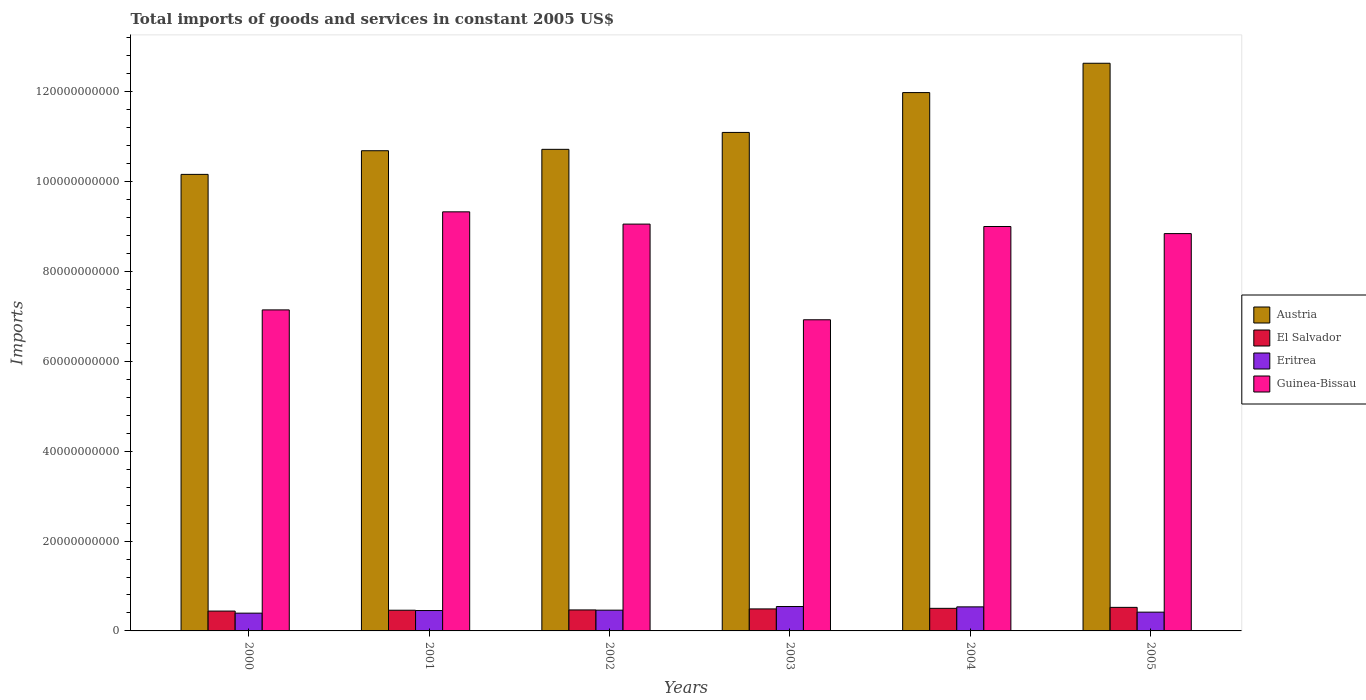How many different coloured bars are there?
Offer a very short reply. 4. How many bars are there on the 4th tick from the left?
Your answer should be compact. 4. How many bars are there on the 5th tick from the right?
Your response must be concise. 4. What is the total imports of goods and services in Guinea-Bissau in 2003?
Offer a terse response. 6.93e+1. Across all years, what is the maximum total imports of goods and services in El Salvador?
Keep it short and to the point. 5.24e+09. Across all years, what is the minimum total imports of goods and services in Eritrea?
Give a very brief answer. 3.96e+09. In which year was the total imports of goods and services in Eritrea minimum?
Make the answer very short. 2000. What is the total total imports of goods and services in Guinea-Bissau in the graph?
Provide a short and direct response. 5.03e+11. What is the difference between the total imports of goods and services in El Salvador in 2004 and that in 2005?
Provide a short and direct response. -2.18e+08. What is the difference between the total imports of goods and services in El Salvador in 2001 and the total imports of goods and services in Austria in 2004?
Make the answer very short. -1.15e+11. What is the average total imports of goods and services in Austria per year?
Your answer should be compact. 1.12e+11. In the year 2005, what is the difference between the total imports of goods and services in Guinea-Bissau and total imports of goods and services in El Salvador?
Your answer should be compact. 8.32e+1. What is the ratio of the total imports of goods and services in Austria in 2000 to that in 2002?
Give a very brief answer. 0.95. Is the difference between the total imports of goods and services in Guinea-Bissau in 2001 and 2005 greater than the difference between the total imports of goods and services in El Salvador in 2001 and 2005?
Provide a succinct answer. Yes. What is the difference between the highest and the second highest total imports of goods and services in Guinea-Bissau?
Keep it short and to the point. 2.73e+09. What is the difference between the highest and the lowest total imports of goods and services in Eritrea?
Your response must be concise. 1.47e+09. In how many years, is the total imports of goods and services in Eritrea greater than the average total imports of goods and services in Eritrea taken over all years?
Provide a succinct answer. 2. Is the sum of the total imports of goods and services in Guinea-Bissau in 2004 and 2005 greater than the maximum total imports of goods and services in Eritrea across all years?
Provide a succinct answer. Yes. What does the 4th bar from the left in 2001 represents?
Offer a very short reply. Guinea-Bissau. What does the 3rd bar from the right in 2001 represents?
Keep it short and to the point. El Salvador. Is it the case that in every year, the sum of the total imports of goods and services in Austria and total imports of goods and services in Eritrea is greater than the total imports of goods and services in Guinea-Bissau?
Your answer should be compact. Yes. How many bars are there?
Offer a terse response. 24. How many years are there in the graph?
Offer a terse response. 6. Are the values on the major ticks of Y-axis written in scientific E-notation?
Provide a short and direct response. No. Does the graph contain any zero values?
Keep it short and to the point. No. Does the graph contain grids?
Your answer should be compact. No. How many legend labels are there?
Offer a very short reply. 4. How are the legend labels stacked?
Keep it short and to the point. Vertical. What is the title of the graph?
Provide a short and direct response. Total imports of goods and services in constant 2005 US$. What is the label or title of the Y-axis?
Keep it short and to the point. Imports. What is the Imports of Austria in 2000?
Provide a succinct answer. 1.02e+11. What is the Imports in El Salvador in 2000?
Your answer should be compact. 4.42e+09. What is the Imports in Eritrea in 2000?
Ensure brevity in your answer.  3.96e+09. What is the Imports in Guinea-Bissau in 2000?
Your answer should be very brief. 7.15e+1. What is the Imports in Austria in 2001?
Keep it short and to the point. 1.07e+11. What is the Imports of El Salvador in 2001?
Give a very brief answer. 4.61e+09. What is the Imports in Eritrea in 2001?
Your answer should be compact. 4.54e+09. What is the Imports of Guinea-Bissau in 2001?
Your answer should be very brief. 9.33e+1. What is the Imports of Austria in 2002?
Offer a terse response. 1.07e+11. What is the Imports of El Salvador in 2002?
Make the answer very short. 4.67e+09. What is the Imports in Eritrea in 2002?
Your answer should be compact. 4.62e+09. What is the Imports in Guinea-Bissau in 2002?
Provide a succinct answer. 9.06e+1. What is the Imports in Austria in 2003?
Ensure brevity in your answer.  1.11e+11. What is the Imports of El Salvador in 2003?
Your response must be concise. 4.90e+09. What is the Imports in Eritrea in 2003?
Offer a very short reply. 5.43e+09. What is the Imports in Guinea-Bissau in 2003?
Give a very brief answer. 6.93e+1. What is the Imports in Austria in 2004?
Offer a very short reply. 1.20e+11. What is the Imports in El Salvador in 2004?
Make the answer very short. 5.03e+09. What is the Imports of Eritrea in 2004?
Your response must be concise. 5.35e+09. What is the Imports in Guinea-Bissau in 2004?
Ensure brevity in your answer.  9.00e+1. What is the Imports in Austria in 2005?
Give a very brief answer. 1.26e+11. What is the Imports in El Salvador in 2005?
Your answer should be very brief. 5.24e+09. What is the Imports in Eritrea in 2005?
Keep it short and to the point. 4.18e+09. What is the Imports in Guinea-Bissau in 2005?
Provide a short and direct response. 8.84e+1. Across all years, what is the maximum Imports of Austria?
Your answer should be very brief. 1.26e+11. Across all years, what is the maximum Imports of El Salvador?
Give a very brief answer. 5.24e+09. Across all years, what is the maximum Imports in Eritrea?
Your response must be concise. 5.43e+09. Across all years, what is the maximum Imports in Guinea-Bissau?
Provide a succinct answer. 9.33e+1. Across all years, what is the minimum Imports in Austria?
Ensure brevity in your answer.  1.02e+11. Across all years, what is the minimum Imports of El Salvador?
Keep it short and to the point. 4.42e+09. Across all years, what is the minimum Imports in Eritrea?
Offer a terse response. 3.96e+09. Across all years, what is the minimum Imports in Guinea-Bissau?
Your answer should be compact. 6.93e+1. What is the total Imports in Austria in the graph?
Your answer should be very brief. 6.73e+11. What is the total Imports in El Salvador in the graph?
Give a very brief answer. 2.89e+1. What is the total Imports in Eritrea in the graph?
Provide a short and direct response. 2.81e+1. What is the total Imports in Guinea-Bissau in the graph?
Make the answer very short. 5.03e+11. What is the difference between the Imports in Austria in 2000 and that in 2001?
Your answer should be compact. -5.26e+09. What is the difference between the Imports of El Salvador in 2000 and that in 2001?
Make the answer very short. -1.87e+08. What is the difference between the Imports of Eritrea in 2000 and that in 2001?
Your response must be concise. -5.78e+08. What is the difference between the Imports in Guinea-Bissau in 2000 and that in 2001?
Offer a very short reply. -2.18e+1. What is the difference between the Imports in Austria in 2000 and that in 2002?
Your answer should be compact. -5.58e+09. What is the difference between the Imports of El Salvador in 2000 and that in 2002?
Your response must be concise. -2.54e+08. What is the difference between the Imports of Eritrea in 2000 and that in 2002?
Your answer should be very brief. -6.64e+08. What is the difference between the Imports in Guinea-Bissau in 2000 and that in 2002?
Provide a short and direct response. -1.91e+1. What is the difference between the Imports of Austria in 2000 and that in 2003?
Provide a short and direct response. -9.34e+09. What is the difference between the Imports in El Salvador in 2000 and that in 2003?
Offer a terse response. -4.81e+08. What is the difference between the Imports in Eritrea in 2000 and that in 2003?
Offer a terse response. -1.47e+09. What is the difference between the Imports in Guinea-Bissau in 2000 and that in 2003?
Keep it short and to the point. 2.20e+09. What is the difference between the Imports of Austria in 2000 and that in 2004?
Offer a terse response. -1.82e+1. What is the difference between the Imports of El Salvador in 2000 and that in 2004?
Your response must be concise. -6.08e+08. What is the difference between the Imports in Eritrea in 2000 and that in 2004?
Offer a terse response. -1.40e+09. What is the difference between the Imports of Guinea-Bissau in 2000 and that in 2004?
Give a very brief answer. -1.86e+1. What is the difference between the Imports of Austria in 2000 and that in 2005?
Provide a succinct answer. -2.47e+1. What is the difference between the Imports of El Salvador in 2000 and that in 2005?
Offer a terse response. -8.26e+08. What is the difference between the Imports of Eritrea in 2000 and that in 2005?
Provide a succinct answer. -2.19e+08. What is the difference between the Imports in Guinea-Bissau in 2000 and that in 2005?
Your answer should be very brief. -1.70e+1. What is the difference between the Imports of Austria in 2001 and that in 2002?
Provide a short and direct response. -3.12e+08. What is the difference between the Imports in El Salvador in 2001 and that in 2002?
Give a very brief answer. -6.77e+07. What is the difference between the Imports of Eritrea in 2001 and that in 2002?
Make the answer very short. -8.56e+07. What is the difference between the Imports of Guinea-Bissau in 2001 and that in 2002?
Your answer should be very brief. 2.73e+09. What is the difference between the Imports of Austria in 2001 and that in 2003?
Your response must be concise. -4.07e+09. What is the difference between the Imports in El Salvador in 2001 and that in 2003?
Ensure brevity in your answer.  -2.94e+08. What is the difference between the Imports of Eritrea in 2001 and that in 2003?
Provide a succinct answer. -8.95e+08. What is the difference between the Imports in Guinea-Bissau in 2001 and that in 2003?
Provide a succinct answer. 2.40e+1. What is the difference between the Imports in Austria in 2001 and that in 2004?
Offer a terse response. -1.29e+1. What is the difference between the Imports in El Salvador in 2001 and that in 2004?
Provide a short and direct response. -4.21e+08. What is the difference between the Imports of Eritrea in 2001 and that in 2004?
Your answer should be compact. -8.19e+08. What is the difference between the Imports in Guinea-Bissau in 2001 and that in 2004?
Give a very brief answer. 3.27e+09. What is the difference between the Imports in Austria in 2001 and that in 2005?
Ensure brevity in your answer.  -1.95e+1. What is the difference between the Imports of El Salvador in 2001 and that in 2005?
Your answer should be very brief. -6.39e+08. What is the difference between the Imports in Eritrea in 2001 and that in 2005?
Provide a short and direct response. 3.59e+08. What is the difference between the Imports of Guinea-Bissau in 2001 and that in 2005?
Offer a very short reply. 4.84e+09. What is the difference between the Imports of Austria in 2002 and that in 2003?
Your answer should be compact. -3.76e+09. What is the difference between the Imports of El Salvador in 2002 and that in 2003?
Provide a short and direct response. -2.27e+08. What is the difference between the Imports in Eritrea in 2002 and that in 2003?
Ensure brevity in your answer.  -8.09e+08. What is the difference between the Imports of Guinea-Bissau in 2002 and that in 2003?
Make the answer very short. 2.13e+1. What is the difference between the Imports in Austria in 2002 and that in 2004?
Offer a very short reply. -1.26e+1. What is the difference between the Imports in El Salvador in 2002 and that in 2004?
Keep it short and to the point. -3.53e+08. What is the difference between the Imports in Eritrea in 2002 and that in 2004?
Your response must be concise. -7.33e+08. What is the difference between the Imports in Guinea-Bissau in 2002 and that in 2004?
Ensure brevity in your answer.  5.35e+08. What is the difference between the Imports of Austria in 2002 and that in 2005?
Provide a short and direct response. -1.92e+1. What is the difference between the Imports of El Salvador in 2002 and that in 2005?
Give a very brief answer. -5.72e+08. What is the difference between the Imports of Eritrea in 2002 and that in 2005?
Offer a very short reply. 4.44e+08. What is the difference between the Imports of Guinea-Bissau in 2002 and that in 2005?
Give a very brief answer. 2.11e+09. What is the difference between the Imports in Austria in 2003 and that in 2004?
Offer a very short reply. -8.87e+09. What is the difference between the Imports in El Salvador in 2003 and that in 2004?
Keep it short and to the point. -1.27e+08. What is the difference between the Imports of Eritrea in 2003 and that in 2004?
Provide a succinct answer. 7.59e+07. What is the difference between the Imports in Guinea-Bissau in 2003 and that in 2004?
Ensure brevity in your answer.  -2.08e+1. What is the difference between the Imports of Austria in 2003 and that in 2005?
Your answer should be compact. -1.54e+1. What is the difference between the Imports of El Salvador in 2003 and that in 2005?
Give a very brief answer. -3.45e+08. What is the difference between the Imports of Eritrea in 2003 and that in 2005?
Give a very brief answer. 1.25e+09. What is the difference between the Imports in Guinea-Bissau in 2003 and that in 2005?
Ensure brevity in your answer.  -1.92e+1. What is the difference between the Imports of Austria in 2004 and that in 2005?
Give a very brief answer. -6.53e+09. What is the difference between the Imports in El Salvador in 2004 and that in 2005?
Provide a short and direct response. -2.18e+08. What is the difference between the Imports in Eritrea in 2004 and that in 2005?
Offer a very short reply. 1.18e+09. What is the difference between the Imports of Guinea-Bissau in 2004 and that in 2005?
Keep it short and to the point. 1.58e+09. What is the difference between the Imports in Austria in 2000 and the Imports in El Salvador in 2001?
Offer a terse response. 9.70e+1. What is the difference between the Imports of Austria in 2000 and the Imports of Eritrea in 2001?
Give a very brief answer. 9.71e+1. What is the difference between the Imports in Austria in 2000 and the Imports in Guinea-Bissau in 2001?
Your answer should be compact. 8.34e+09. What is the difference between the Imports in El Salvador in 2000 and the Imports in Eritrea in 2001?
Your answer should be very brief. -1.17e+08. What is the difference between the Imports in El Salvador in 2000 and the Imports in Guinea-Bissau in 2001?
Provide a short and direct response. -8.89e+1. What is the difference between the Imports in Eritrea in 2000 and the Imports in Guinea-Bissau in 2001?
Keep it short and to the point. -8.93e+1. What is the difference between the Imports in Austria in 2000 and the Imports in El Salvador in 2002?
Provide a succinct answer. 9.69e+1. What is the difference between the Imports of Austria in 2000 and the Imports of Eritrea in 2002?
Make the answer very short. 9.70e+1. What is the difference between the Imports of Austria in 2000 and the Imports of Guinea-Bissau in 2002?
Offer a very short reply. 1.11e+1. What is the difference between the Imports in El Salvador in 2000 and the Imports in Eritrea in 2002?
Your response must be concise. -2.03e+08. What is the difference between the Imports of El Salvador in 2000 and the Imports of Guinea-Bissau in 2002?
Offer a terse response. -8.61e+1. What is the difference between the Imports in Eritrea in 2000 and the Imports in Guinea-Bissau in 2002?
Give a very brief answer. -8.66e+1. What is the difference between the Imports of Austria in 2000 and the Imports of El Salvador in 2003?
Provide a short and direct response. 9.67e+1. What is the difference between the Imports in Austria in 2000 and the Imports in Eritrea in 2003?
Offer a terse response. 9.62e+1. What is the difference between the Imports of Austria in 2000 and the Imports of Guinea-Bissau in 2003?
Make the answer very short. 3.24e+1. What is the difference between the Imports in El Salvador in 2000 and the Imports in Eritrea in 2003?
Your answer should be compact. -1.01e+09. What is the difference between the Imports of El Salvador in 2000 and the Imports of Guinea-Bissau in 2003?
Your response must be concise. -6.48e+1. What is the difference between the Imports of Eritrea in 2000 and the Imports of Guinea-Bissau in 2003?
Offer a terse response. -6.53e+1. What is the difference between the Imports in Austria in 2000 and the Imports in El Salvador in 2004?
Keep it short and to the point. 9.66e+1. What is the difference between the Imports in Austria in 2000 and the Imports in Eritrea in 2004?
Your response must be concise. 9.63e+1. What is the difference between the Imports in Austria in 2000 and the Imports in Guinea-Bissau in 2004?
Give a very brief answer. 1.16e+1. What is the difference between the Imports of El Salvador in 2000 and the Imports of Eritrea in 2004?
Your answer should be compact. -9.36e+08. What is the difference between the Imports in El Salvador in 2000 and the Imports in Guinea-Bissau in 2004?
Your answer should be very brief. -8.56e+1. What is the difference between the Imports of Eritrea in 2000 and the Imports of Guinea-Bissau in 2004?
Give a very brief answer. -8.61e+1. What is the difference between the Imports of Austria in 2000 and the Imports of El Salvador in 2005?
Your response must be concise. 9.64e+1. What is the difference between the Imports of Austria in 2000 and the Imports of Eritrea in 2005?
Offer a terse response. 9.74e+1. What is the difference between the Imports of Austria in 2000 and the Imports of Guinea-Bissau in 2005?
Provide a short and direct response. 1.32e+1. What is the difference between the Imports of El Salvador in 2000 and the Imports of Eritrea in 2005?
Offer a terse response. 2.41e+08. What is the difference between the Imports of El Salvador in 2000 and the Imports of Guinea-Bissau in 2005?
Make the answer very short. -8.40e+1. What is the difference between the Imports of Eritrea in 2000 and the Imports of Guinea-Bissau in 2005?
Offer a terse response. -8.45e+1. What is the difference between the Imports in Austria in 2001 and the Imports in El Salvador in 2002?
Offer a terse response. 1.02e+11. What is the difference between the Imports in Austria in 2001 and the Imports in Eritrea in 2002?
Make the answer very short. 1.02e+11. What is the difference between the Imports in Austria in 2001 and the Imports in Guinea-Bissau in 2002?
Provide a succinct answer. 1.63e+1. What is the difference between the Imports in El Salvador in 2001 and the Imports in Eritrea in 2002?
Your answer should be very brief. -1.62e+07. What is the difference between the Imports in El Salvador in 2001 and the Imports in Guinea-Bissau in 2002?
Ensure brevity in your answer.  -8.59e+1. What is the difference between the Imports of Eritrea in 2001 and the Imports of Guinea-Bissau in 2002?
Offer a very short reply. -8.60e+1. What is the difference between the Imports of Austria in 2001 and the Imports of El Salvador in 2003?
Offer a very short reply. 1.02e+11. What is the difference between the Imports of Austria in 2001 and the Imports of Eritrea in 2003?
Your answer should be compact. 1.01e+11. What is the difference between the Imports in Austria in 2001 and the Imports in Guinea-Bissau in 2003?
Provide a short and direct response. 3.76e+1. What is the difference between the Imports in El Salvador in 2001 and the Imports in Eritrea in 2003?
Make the answer very short. -8.25e+08. What is the difference between the Imports in El Salvador in 2001 and the Imports in Guinea-Bissau in 2003?
Keep it short and to the point. -6.47e+1. What is the difference between the Imports in Eritrea in 2001 and the Imports in Guinea-Bissau in 2003?
Make the answer very short. -6.47e+1. What is the difference between the Imports in Austria in 2001 and the Imports in El Salvador in 2004?
Offer a very short reply. 1.02e+11. What is the difference between the Imports of Austria in 2001 and the Imports of Eritrea in 2004?
Give a very brief answer. 1.02e+11. What is the difference between the Imports of Austria in 2001 and the Imports of Guinea-Bissau in 2004?
Offer a terse response. 1.69e+1. What is the difference between the Imports of El Salvador in 2001 and the Imports of Eritrea in 2004?
Give a very brief answer. -7.49e+08. What is the difference between the Imports in El Salvador in 2001 and the Imports in Guinea-Bissau in 2004?
Provide a short and direct response. -8.54e+1. What is the difference between the Imports of Eritrea in 2001 and the Imports of Guinea-Bissau in 2004?
Your answer should be compact. -8.55e+1. What is the difference between the Imports of Austria in 2001 and the Imports of El Salvador in 2005?
Your response must be concise. 1.02e+11. What is the difference between the Imports of Austria in 2001 and the Imports of Eritrea in 2005?
Ensure brevity in your answer.  1.03e+11. What is the difference between the Imports in Austria in 2001 and the Imports in Guinea-Bissau in 2005?
Keep it short and to the point. 1.84e+1. What is the difference between the Imports in El Salvador in 2001 and the Imports in Eritrea in 2005?
Your response must be concise. 4.28e+08. What is the difference between the Imports in El Salvador in 2001 and the Imports in Guinea-Bissau in 2005?
Offer a very short reply. -8.38e+1. What is the difference between the Imports in Eritrea in 2001 and the Imports in Guinea-Bissau in 2005?
Provide a short and direct response. -8.39e+1. What is the difference between the Imports in Austria in 2002 and the Imports in El Salvador in 2003?
Provide a short and direct response. 1.02e+11. What is the difference between the Imports of Austria in 2002 and the Imports of Eritrea in 2003?
Provide a succinct answer. 1.02e+11. What is the difference between the Imports in Austria in 2002 and the Imports in Guinea-Bissau in 2003?
Give a very brief answer. 3.79e+1. What is the difference between the Imports in El Salvador in 2002 and the Imports in Eritrea in 2003?
Offer a terse response. -7.57e+08. What is the difference between the Imports of El Salvador in 2002 and the Imports of Guinea-Bissau in 2003?
Offer a terse response. -6.46e+1. What is the difference between the Imports of Eritrea in 2002 and the Imports of Guinea-Bissau in 2003?
Your response must be concise. -6.46e+1. What is the difference between the Imports of Austria in 2002 and the Imports of El Salvador in 2004?
Provide a short and direct response. 1.02e+11. What is the difference between the Imports in Austria in 2002 and the Imports in Eritrea in 2004?
Offer a very short reply. 1.02e+11. What is the difference between the Imports of Austria in 2002 and the Imports of Guinea-Bissau in 2004?
Your response must be concise. 1.72e+1. What is the difference between the Imports of El Salvador in 2002 and the Imports of Eritrea in 2004?
Provide a succinct answer. -6.82e+08. What is the difference between the Imports in El Salvador in 2002 and the Imports in Guinea-Bissau in 2004?
Provide a succinct answer. -8.53e+1. What is the difference between the Imports of Eritrea in 2002 and the Imports of Guinea-Bissau in 2004?
Your answer should be compact. -8.54e+1. What is the difference between the Imports in Austria in 2002 and the Imports in El Salvador in 2005?
Give a very brief answer. 1.02e+11. What is the difference between the Imports of Austria in 2002 and the Imports of Eritrea in 2005?
Give a very brief answer. 1.03e+11. What is the difference between the Imports in Austria in 2002 and the Imports in Guinea-Bissau in 2005?
Your answer should be very brief. 1.88e+1. What is the difference between the Imports in El Salvador in 2002 and the Imports in Eritrea in 2005?
Offer a very short reply. 4.96e+08. What is the difference between the Imports in El Salvador in 2002 and the Imports in Guinea-Bissau in 2005?
Provide a short and direct response. -8.38e+1. What is the difference between the Imports in Eritrea in 2002 and the Imports in Guinea-Bissau in 2005?
Offer a very short reply. -8.38e+1. What is the difference between the Imports of Austria in 2003 and the Imports of El Salvador in 2004?
Offer a terse response. 1.06e+11. What is the difference between the Imports in Austria in 2003 and the Imports in Eritrea in 2004?
Your response must be concise. 1.06e+11. What is the difference between the Imports in Austria in 2003 and the Imports in Guinea-Bissau in 2004?
Provide a short and direct response. 2.09e+1. What is the difference between the Imports of El Salvador in 2003 and the Imports of Eritrea in 2004?
Offer a very short reply. -4.55e+08. What is the difference between the Imports of El Salvador in 2003 and the Imports of Guinea-Bissau in 2004?
Offer a terse response. -8.51e+1. What is the difference between the Imports in Eritrea in 2003 and the Imports in Guinea-Bissau in 2004?
Provide a succinct answer. -8.46e+1. What is the difference between the Imports in Austria in 2003 and the Imports in El Salvador in 2005?
Provide a short and direct response. 1.06e+11. What is the difference between the Imports in Austria in 2003 and the Imports in Eritrea in 2005?
Give a very brief answer. 1.07e+11. What is the difference between the Imports in Austria in 2003 and the Imports in Guinea-Bissau in 2005?
Provide a succinct answer. 2.25e+1. What is the difference between the Imports in El Salvador in 2003 and the Imports in Eritrea in 2005?
Offer a terse response. 7.23e+08. What is the difference between the Imports in El Salvador in 2003 and the Imports in Guinea-Bissau in 2005?
Make the answer very short. -8.35e+1. What is the difference between the Imports in Eritrea in 2003 and the Imports in Guinea-Bissau in 2005?
Give a very brief answer. -8.30e+1. What is the difference between the Imports in Austria in 2004 and the Imports in El Salvador in 2005?
Offer a terse response. 1.15e+11. What is the difference between the Imports in Austria in 2004 and the Imports in Eritrea in 2005?
Provide a short and direct response. 1.16e+11. What is the difference between the Imports in Austria in 2004 and the Imports in Guinea-Bissau in 2005?
Offer a very short reply. 3.14e+1. What is the difference between the Imports in El Salvador in 2004 and the Imports in Eritrea in 2005?
Provide a short and direct response. 8.49e+08. What is the difference between the Imports in El Salvador in 2004 and the Imports in Guinea-Bissau in 2005?
Offer a very short reply. -8.34e+1. What is the difference between the Imports of Eritrea in 2004 and the Imports of Guinea-Bissau in 2005?
Your response must be concise. -8.31e+1. What is the average Imports of Austria per year?
Provide a succinct answer. 1.12e+11. What is the average Imports in El Salvador per year?
Your answer should be very brief. 4.81e+09. What is the average Imports of Eritrea per year?
Give a very brief answer. 4.68e+09. What is the average Imports in Guinea-Bissau per year?
Give a very brief answer. 8.38e+1. In the year 2000, what is the difference between the Imports of Austria and Imports of El Salvador?
Your answer should be compact. 9.72e+1. In the year 2000, what is the difference between the Imports in Austria and Imports in Eritrea?
Give a very brief answer. 9.77e+1. In the year 2000, what is the difference between the Imports in Austria and Imports in Guinea-Bissau?
Make the answer very short. 3.02e+1. In the year 2000, what is the difference between the Imports of El Salvador and Imports of Eritrea?
Make the answer very short. 4.61e+08. In the year 2000, what is the difference between the Imports in El Salvador and Imports in Guinea-Bissau?
Give a very brief answer. -6.70e+1. In the year 2000, what is the difference between the Imports of Eritrea and Imports of Guinea-Bissau?
Ensure brevity in your answer.  -6.75e+1. In the year 2001, what is the difference between the Imports in Austria and Imports in El Salvador?
Your response must be concise. 1.02e+11. In the year 2001, what is the difference between the Imports of Austria and Imports of Eritrea?
Provide a succinct answer. 1.02e+11. In the year 2001, what is the difference between the Imports in Austria and Imports in Guinea-Bissau?
Give a very brief answer. 1.36e+1. In the year 2001, what is the difference between the Imports in El Salvador and Imports in Eritrea?
Your answer should be very brief. 6.93e+07. In the year 2001, what is the difference between the Imports in El Salvador and Imports in Guinea-Bissau?
Ensure brevity in your answer.  -8.87e+1. In the year 2001, what is the difference between the Imports of Eritrea and Imports of Guinea-Bissau?
Keep it short and to the point. -8.87e+1. In the year 2002, what is the difference between the Imports in Austria and Imports in El Salvador?
Provide a short and direct response. 1.03e+11. In the year 2002, what is the difference between the Imports of Austria and Imports of Eritrea?
Offer a terse response. 1.03e+11. In the year 2002, what is the difference between the Imports of Austria and Imports of Guinea-Bissau?
Offer a very short reply. 1.66e+1. In the year 2002, what is the difference between the Imports in El Salvador and Imports in Eritrea?
Provide a succinct answer. 5.15e+07. In the year 2002, what is the difference between the Imports of El Salvador and Imports of Guinea-Bissau?
Provide a succinct answer. -8.59e+1. In the year 2002, what is the difference between the Imports in Eritrea and Imports in Guinea-Bissau?
Provide a succinct answer. -8.59e+1. In the year 2003, what is the difference between the Imports of Austria and Imports of El Salvador?
Ensure brevity in your answer.  1.06e+11. In the year 2003, what is the difference between the Imports of Austria and Imports of Eritrea?
Provide a succinct answer. 1.06e+11. In the year 2003, what is the difference between the Imports of Austria and Imports of Guinea-Bissau?
Ensure brevity in your answer.  4.17e+1. In the year 2003, what is the difference between the Imports in El Salvador and Imports in Eritrea?
Provide a succinct answer. -5.31e+08. In the year 2003, what is the difference between the Imports in El Salvador and Imports in Guinea-Bissau?
Provide a short and direct response. -6.44e+1. In the year 2003, what is the difference between the Imports in Eritrea and Imports in Guinea-Bissau?
Your answer should be very brief. -6.38e+1. In the year 2004, what is the difference between the Imports in Austria and Imports in El Salvador?
Keep it short and to the point. 1.15e+11. In the year 2004, what is the difference between the Imports in Austria and Imports in Eritrea?
Your answer should be very brief. 1.14e+11. In the year 2004, what is the difference between the Imports of Austria and Imports of Guinea-Bissau?
Your response must be concise. 2.98e+1. In the year 2004, what is the difference between the Imports of El Salvador and Imports of Eritrea?
Give a very brief answer. -3.28e+08. In the year 2004, what is the difference between the Imports in El Salvador and Imports in Guinea-Bissau?
Offer a terse response. -8.50e+1. In the year 2004, what is the difference between the Imports of Eritrea and Imports of Guinea-Bissau?
Keep it short and to the point. -8.47e+1. In the year 2005, what is the difference between the Imports in Austria and Imports in El Salvador?
Provide a short and direct response. 1.21e+11. In the year 2005, what is the difference between the Imports of Austria and Imports of Eritrea?
Offer a very short reply. 1.22e+11. In the year 2005, what is the difference between the Imports of Austria and Imports of Guinea-Bissau?
Make the answer very short. 3.79e+1. In the year 2005, what is the difference between the Imports in El Salvador and Imports in Eritrea?
Your response must be concise. 1.07e+09. In the year 2005, what is the difference between the Imports of El Salvador and Imports of Guinea-Bissau?
Keep it short and to the point. -8.32e+1. In the year 2005, what is the difference between the Imports of Eritrea and Imports of Guinea-Bissau?
Provide a succinct answer. -8.43e+1. What is the ratio of the Imports in Austria in 2000 to that in 2001?
Your answer should be compact. 0.95. What is the ratio of the Imports in El Salvador in 2000 to that in 2001?
Provide a short and direct response. 0.96. What is the ratio of the Imports in Eritrea in 2000 to that in 2001?
Ensure brevity in your answer.  0.87. What is the ratio of the Imports in Guinea-Bissau in 2000 to that in 2001?
Keep it short and to the point. 0.77. What is the ratio of the Imports of Austria in 2000 to that in 2002?
Your answer should be compact. 0.95. What is the ratio of the Imports in El Salvador in 2000 to that in 2002?
Provide a short and direct response. 0.95. What is the ratio of the Imports of Eritrea in 2000 to that in 2002?
Your answer should be compact. 0.86. What is the ratio of the Imports in Guinea-Bissau in 2000 to that in 2002?
Provide a short and direct response. 0.79. What is the ratio of the Imports in Austria in 2000 to that in 2003?
Your answer should be very brief. 0.92. What is the ratio of the Imports in El Salvador in 2000 to that in 2003?
Make the answer very short. 0.9. What is the ratio of the Imports in Eritrea in 2000 to that in 2003?
Offer a very short reply. 0.73. What is the ratio of the Imports in Guinea-Bissau in 2000 to that in 2003?
Ensure brevity in your answer.  1.03. What is the ratio of the Imports in Austria in 2000 to that in 2004?
Offer a terse response. 0.85. What is the ratio of the Imports in El Salvador in 2000 to that in 2004?
Offer a very short reply. 0.88. What is the ratio of the Imports in Eritrea in 2000 to that in 2004?
Offer a terse response. 0.74. What is the ratio of the Imports in Guinea-Bissau in 2000 to that in 2004?
Your response must be concise. 0.79. What is the ratio of the Imports in Austria in 2000 to that in 2005?
Keep it short and to the point. 0.8. What is the ratio of the Imports in El Salvador in 2000 to that in 2005?
Give a very brief answer. 0.84. What is the ratio of the Imports of Eritrea in 2000 to that in 2005?
Provide a short and direct response. 0.95. What is the ratio of the Imports in Guinea-Bissau in 2000 to that in 2005?
Make the answer very short. 0.81. What is the ratio of the Imports of Austria in 2001 to that in 2002?
Provide a short and direct response. 1. What is the ratio of the Imports of El Salvador in 2001 to that in 2002?
Offer a terse response. 0.99. What is the ratio of the Imports in Eritrea in 2001 to that in 2002?
Your answer should be compact. 0.98. What is the ratio of the Imports in Guinea-Bissau in 2001 to that in 2002?
Your answer should be very brief. 1.03. What is the ratio of the Imports of Austria in 2001 to that in 2003?
Make the answer very short. 0.96. What is the ratio of the Imports in El Salvador in 2001 to that in 2003?
Offer a terse response. 0.94. What is the ratio of the Imports in Eritrea in 2001 to that in 2003?
Make the answer very short. 0.84. What is the ratio of the Imports in Guinea-Bissau in 2001 to that in 2003?
Give a very brief answer. 1.35. What is the ratio of the Imports of Austria in 2001 to that in 2004?
Your response must be concise. 0.89. What is the ratio of the Imports of El Salvador in 2001 to that in 2004?
Offer a terse response. 0.92. What is the ratio of the Imports in Eritrea in 2001 to that in 2004?
Your response must be concise. 0.85. What is the ratio of the Imports of Guinea-Bissau in 2001 to that in 2004?
Your answer should be compact. 1.04. What is the ratio of the Imports in Austria in 2001 to that in 2005?
Provide a short and direct response. 0.85. What is the ratio of the Imports of El Salvador in 2001 to that in 2005?
Give a very brief answer. 0.88. What is the ratio of the Imports of Eritrea in 2001 to that in 2005?
Provide a short and direct response. 1.09. What is the ratio of the Imports in Guinea-Bissau in 2001 to that in 2005?
Keep it short and to the point. 1.05. What is the ratio of the Imports of Austria in 2002 to that in 2003?
Give a very brief answer. 0.97. What is the ratio of the Imports of El Salvador in 2002 to that in 2003?
Offer a terse response. 0.95. What is the ratio of the Imports of Eritrea in 2002 to that in 2003?
Offer a terse response. 0.85. What is the ratio of the Imports of Guinea-Bissau in 2002 to that in 2003?
Offer a terse response. 1.31. What is the ratio of the Imports in Austria in 2002 to that in 2004?
Give a very brief answer. 0.89. What is the ratio of the Imports of El Salvador in 2002 to that in 2004?
Provide a short and direct response. 0.93. What is the ratio of the Imports in Eritrea in 2002 to that in 2004?
Keep it short and to the point. 0.86. What is the ratio of the Imports of Guinea-Bissau in 2002 to that in 2004?
Ensure brevity in your answer.  1.01. What is the ratio of the Imports in Austria in 2002 to that in 2005?
Ensure brevity in your answer.  0.85. What is the ratio of the Imports of El Salvador in 2002 to that in 2005?
Provide a succinct answer. 0.89. What is the ratio of the Imports of Eritrea in 2002 to that in 2005?
Provide a short and direct response. 1.11. What is the ratio of the Imports of Guinea-Bissau in 2002 to that in 2005?
Your response must be concise. 1.02. What is the ratio of the Imports in Austria in 2003 to that in 2004?
Keep it short and to the point. 0.93. What is the ratio of the Imports in El Salvador in 2003 to that in 2004?
Your response must be concise. 0.97. What is the ratio of the Imports of Eritrea in 2003 to that in 2004?
Offer a terse response. 1.01. What is the ratio of the Imports in Guinea-Bissau in 2003 to that in 2004?
Your answer should be very brief. 0.77. What is the ratio of the Imports of Austria in 2003 to that in 2005?
Ensure brevity in your answer.  0.88. What is the ratio of the Imports in El Salvador in 2003 to that in 2005?
Make the answer very short. 0.93. What is the ratio of the Imports in Eritrea in 2003 to that in 2005?
Make the answer very short. 1.3. What is the ratio of the Imports of Guinea-Bissau in 2003 to that in 2005?
Provide a succinct answer. 0.78. What is the ratio of the Imports of Austria in 2004 to that in 2005?
Provide a short and direct response. 0.95. What is the ratio of the Imports of El Salvador in 2004 to that in 2005?
Your response must be concise. 0.96. What is the ratio of the Imports of Eritrea in 2004 to that in 2005?
Your answer should be compact. 1.28. What is the ratio of the Imports of Guinea-Bissau in 2004 to that in 2005?
Give a very brief answer. 1.02. What is the difference between the highest and the second highest Imports in Austria?
Ensure brevity in your answer.  6.53e+09. What is the difference between the highest and the second highest Imports of El Salvador?
Offer a very short reply. 2.18e+08. What is the difference between the highest and the second highest Imports of Eritrea?
Your response must be concise. 7.59e+07. What is the difference between the highest and the second highest Imports in Guinea-Bissau?
Give a very brief answer. 2.73e+09. What is the difference between the highest and the lowest Imports of Austria?
Provide a short and direct response. 2.47e+1. What is the difference between the highest and the lowest Imports of El Salvador?
Offer a terse response. 8.26e+08. What is the difference between the highest and the lowest Imports of Eritrea?
Your answer should be very brief. 1.47e+09. What is the difference between the highest and the lowest Imports in Guinea-Bissau?
Your response must be concise. 2.40e+1. 